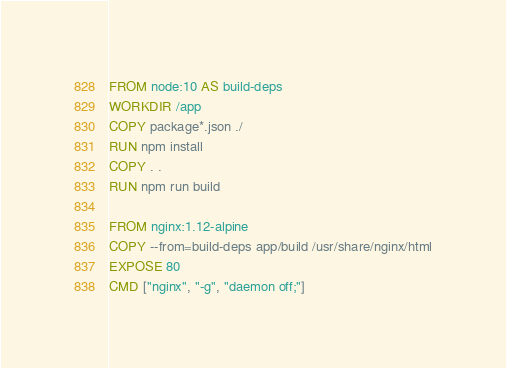<code> <loc_0><loc_0><loc_500><loc_500><_Dockerfile_>FROM node:10 AS build-deps
WORKDIR /app
COPY package*.json ./
RUN npm install 
COPY . .
RUN npm run build 

FROM nginx:1.12-alpine
COPY --from=build-deps app/build /usr/share/nginx/html
EXPOSE 80
CMD ["nginx", "-g", "daemon off;"]</code> 